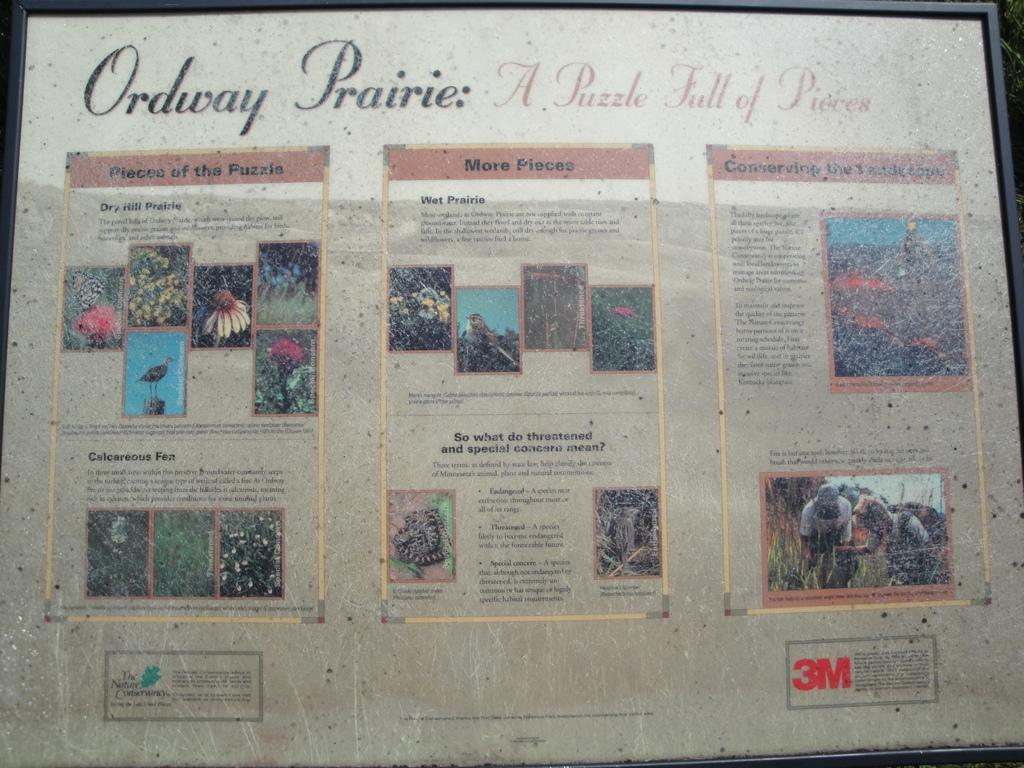<image>
Give a short and clear explanation of the subsequent image. A poster for Ordway Prairie a puzzle full of pieces by 3M. 